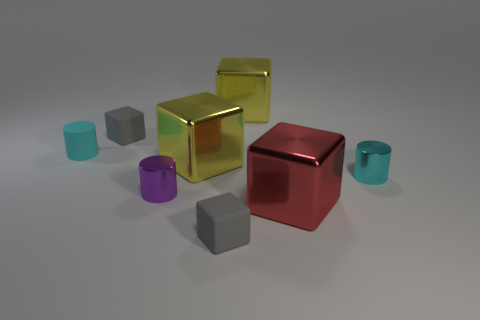How many cylinders are large red metal objects or tiny objects?
Offer a terse response. 3. What size is the cyan object that is made of the same material as the large red thing?
Offer a very short reply. Small. What number of tiny rubber objects are the same color as the matte cylinder?
Provide a short and direct response. 0. There is a small purple metallic cylinder; are there any gray matte cubes in front of it?
Provide a succinct answer. Yes. Do the small cyan rubber object and the tiny gray rubber object that is behind the small rubber cylinder have the same shape?
Provide a succinct answer. No. What number of things are either small rubber cubes behind the red block or small red metallic objects?
Your response must be concise. 1. Are there any other things that have the same material as the purple thing?
Your response must be concise. Yes. How many shiny things are to the right of the small purple object and in front of the tiny cyan metallic object?
Offer a very short reply. 1. How many things are either large cubes behind the large red block or objects that are right of the tiny purple metallic object?
Ensure brevity in your answer.  5. What number of other things are there of the same shape as the large red shiny thing?
Your response must be concise. 4. 